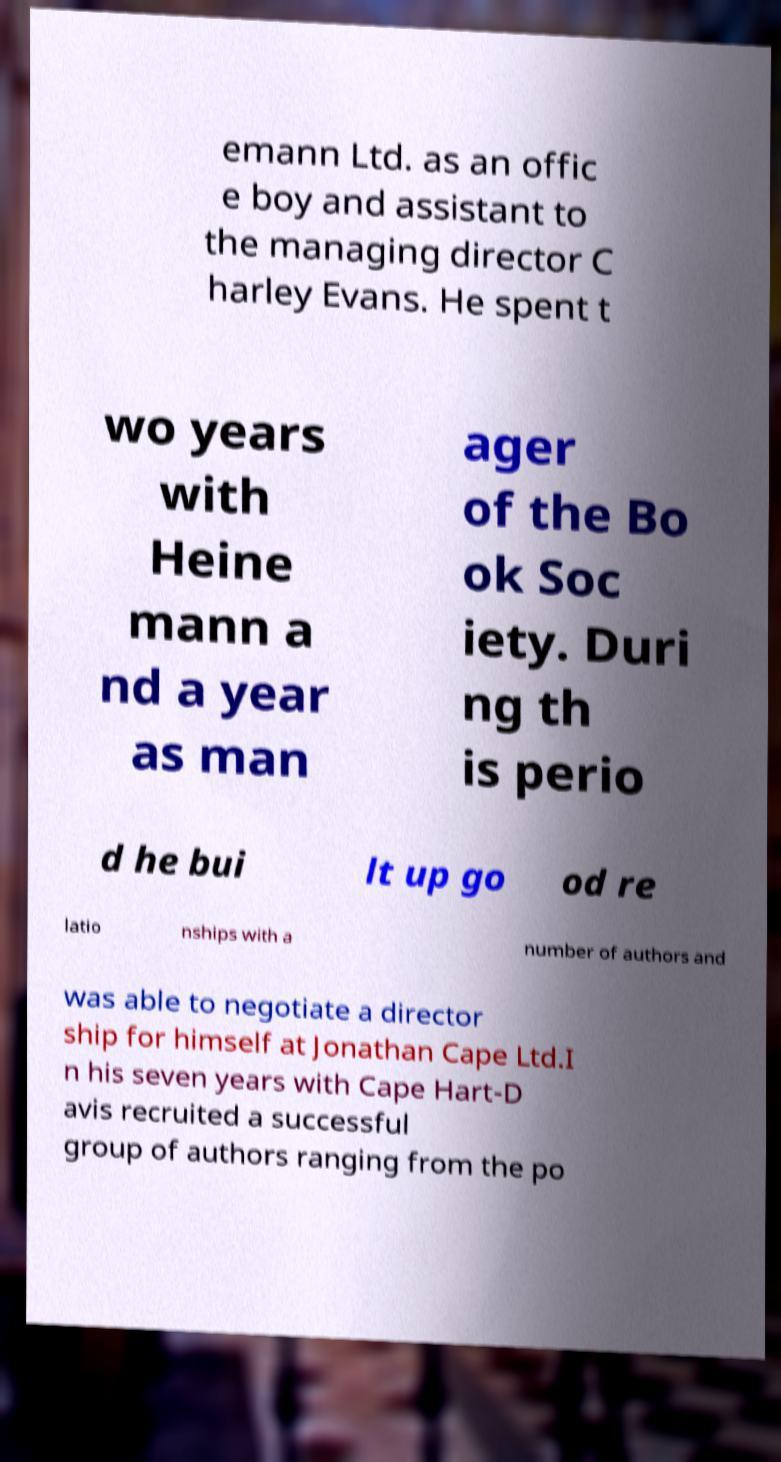Please identify and transcribe the text found in this image. emann Ltd. as an offic e boy and assistant to the managing director C harley Evans. He spent t wo years with Heine mann a nd a year as man ager of the Bo ok Soc iety. Duri ng th is perio d he bui lt up go od re latio nships with a number of authors and was able to negotiate a director ship for himself at Jonathan Cape Ltd.I n his seven years with Cape Hart-D avis recruited a successful group of authors ranging from the po 